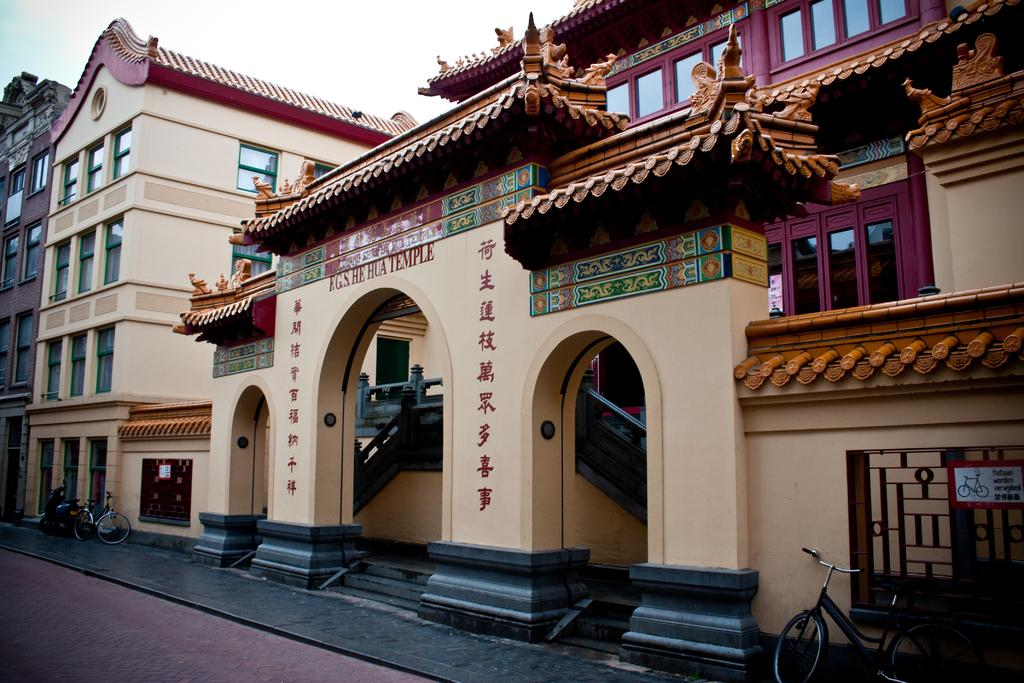What type of building is in the image? There is a heritage building in the image. What features can be seen on the heritage building? The heritage building has windows, stairs, and a gate. What else is present in the image besides the heritage building? There are vehicles in the image. Is there any signage or information related to the heritage building? Yes, there is a board associated with the heritage building. What can be seen in the background of the image? The sky is visible in the background of the image. What type of music can be heard coming from the heritage building in the image? There is no indication of music or any sounds in the image, so it's not possible to determine what, if any, music might be heard. 